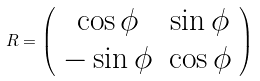Convert formula to latex. <formula><loc_0><loc_0><loc_500><loc_500>R = \left ( \begin{array} { c c } \cos \phi & \sin \phi \\ - \sin \phi & \cos \phi \\ \end{array} \right )</formula> 